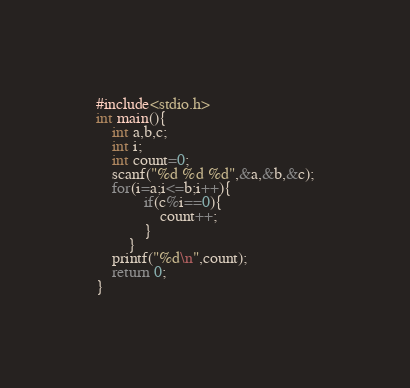<code> <loc_0><loc_0><loc_500><loc_500><_C_>#include<stdio.h>
int main(){
	int a,b,c;
	int i;
	int count=0;
	scanf("%d %d %d",&a,&b,&c);
	for(i=a;i<=b;i++){
			if(c%i==0){
				count++;
			}
		}
	printf("%d\n",count);
	return 0;
}</code> 